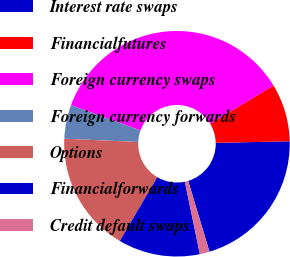Convert chart. <chart><loc_0><loc_0><loc_500><loc_500><pie_chart><fcel>Interest rate swaps<fcel>Financialfutures<fcel>Foreign currency swaps<fcel>Foreign currency forwards<fcel>Options<fcel>Financialforwards<fcel>Credit default swaps<nl><fcel>20.69%<fcel>8.28%<fcel>35.81%<fcel>4.84%<fcel>17.25%<fcel>11.72%<fcel>1.4%<nl></chart> 